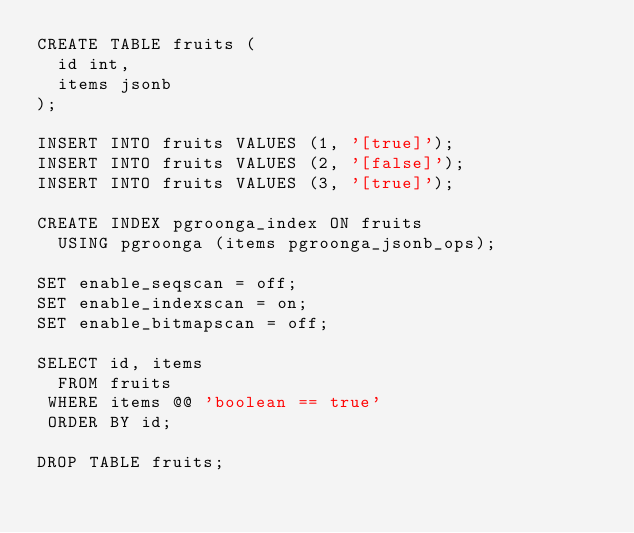<code> <loc_0><loc_0><loc_500><loc_500><_SQL_>CREATE TABLE fruits (
  id int,
  items jsonb
);

INSERT INTO fruits VALUES (1, '[true]');
INSERT INTO fruits VALUES (2, '[false]');
INSERT INTO fruits VALUES (3, '[true]');

CREATE INDEX pgroonga_index ON fruits
  USING pgroonga (items pgroonga_jsonb_ops);

SET enable_seqscan = off;
SET enable_indexscan = on;
SET enable_bitmapscan = off;

SELECT id, items
  FROM fruits
 WHERE items @@ 'boolean == true'
 ORDER BY id;

DROP TABLE fruits;
</code> 